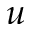Convert formula to latex. <formula><loc_0><loc_0><loc_500><loc_500>u</formula> 